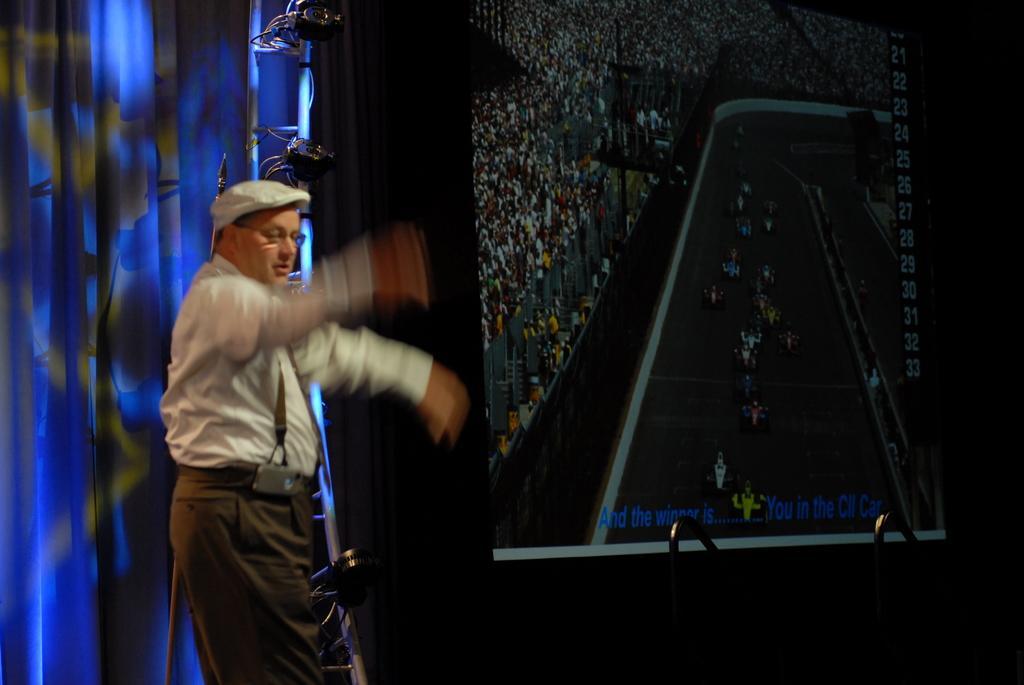Can you describe this image briefly? In this picture we can see a man on the left side of the image, and he wore a cap, beside to him we can see a screen few metal rods and curtains. 